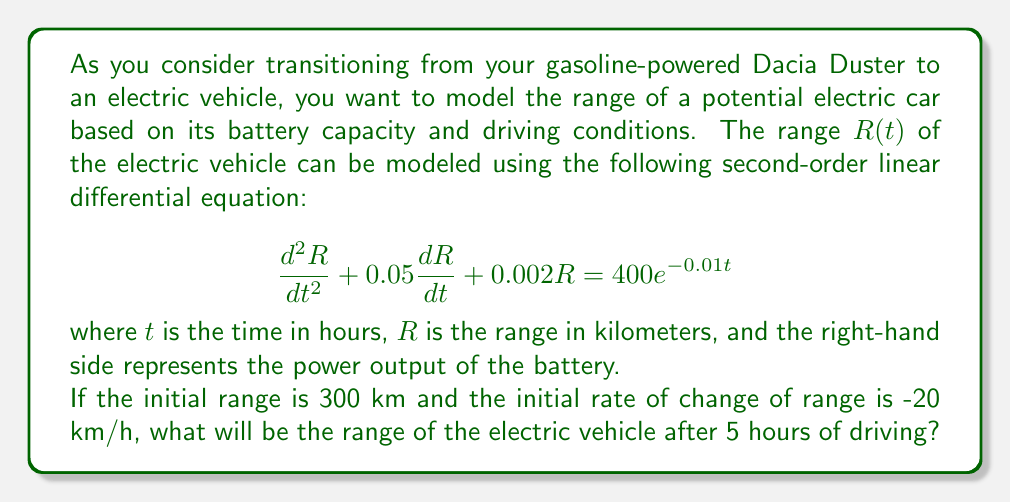Give your solution to this math problem. To solve this problem, we need to follow these steps:

1) First, we identify this as a non-homogeneous second-order linear differential equation.

2) The general solution will be the sum of the complementary function (solution to the homogeneous equation) and the particular integral (a solution that satisfies the full equation).

3) For the complementary function, we solve the characteristic equation:
   $$r^2 + 0.05r + 0.002 = 0$$
   Using the quadratic formula, we get:
   $$r = \frac{-0.05 \pm \sqrt{0.05^2 - 4(1)(0.002)}}{2(1)} = -0.025 \pm 0.0354i$$

4) Therefore, the complementary function is:
   $$R_c(t) = e^{-0.025t}(A\cos(0.0354t) + B\sin(0.0354t))$$

5) For the particular integral, we guess a solution of the form:
   $$R_p(t) = Ce^{-0.01t}$$
   Substituting this into the original equation and solving for C gives:
   $$C = \frac{400}{(-0.01)^2 + 0.05(-0.01) + 0.002} = 200,000$$

6) The general solution is thus:
   $$R(t) = e^{-0.025t}(A\cos(0.0354t) + B\sin(0.0354t)) + 200,000e^{-0.01t}$$

7) Using the initial conditions:
   $R(0) = 300$ and $R'(0) = -20$
   We can solve for A and B:
   $$A = -199,700$$
   $$B = -5,480$$

8) The final solution is:
   $$R(t) = e^{-0.025t}(-199,700\cos(0.0354t) - 5,480\sin(0.0354t)) + 200,000e^{-0.01t}$$

9) To find the range after 5 hours, we substitute t = 5 into this equation.
Answer: The range of the electric vehicle after 5 hours of driving is approximately 284.7 km. 